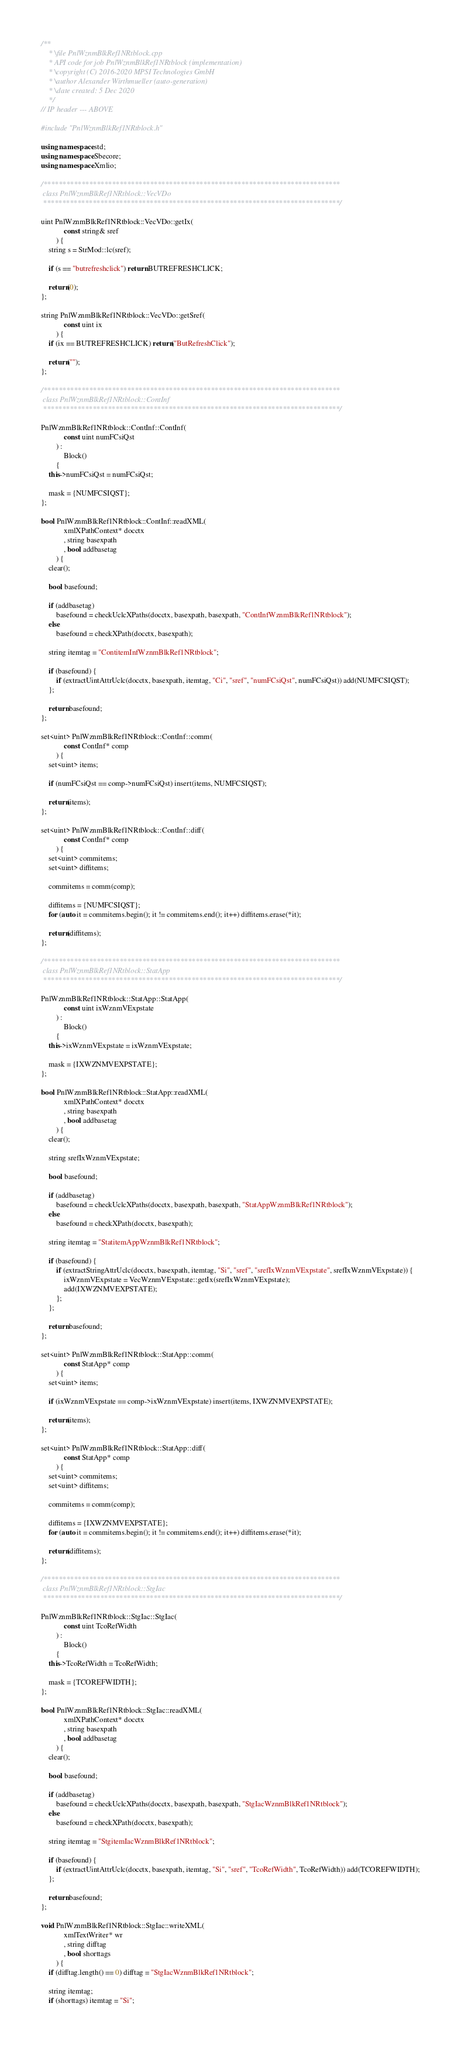Convert code to text. <code><loc_0><loc_0><loc_500><loc_500><_C++_>/**
	* \file PnlWznmBlkRef1NRtblock.cpp
	* API code for job PnlWznmBlkRef1NRtblock (implementation)
	* \copyright (C) 2016-2020 MPSI Technologies GmbH
	* \author Alexander Wirthmueller (auto-generation)
	* \date created: 5 Dec 2020
	*/
// IP header --- ABOVE

#include "PnlWznmBlkRef1NRtblock.h"

using namespace std;
using namespace Sbecore;
using namespace Xmlio;

/******************************************************************************
 class PnlWznmBlkRef1NRtblock::VecVDo
 ******************************************************************************/

uint PnlWznmBlkRef1NRtblock::VecVDo::getIx(
			const string& sref
		) {
	string s = StrMod::lc(sref);

	if (s == "butrefreshclick") return BUTREFRESHCLICK;

	return(0);
};

string PnlWznmBlkRef1NRtblock::VecVDo::getSref(
			const uint ix
		) {
	if (ix == BUTREFRESHCLICK) return("ButRefreshClick");

	return("");
};

/******************************************************************************
 class PnlWznmBlkRef1NRtblock::ContInf
 ******************************************************************************/

PnlWznmBlkRef1NRtblock::ContInf::ContInf(
			const uint numFCsiQst
		) :
			Block()
		{
	this->numFCsiQst = numFCsiQst;

	mask = {NUMFCSIQST};
};

bool PnlWznmBlkRef1NRtblock::ContInf::readXML(
			xmlXPathContext* docctx
			, string basexpath
			, bool addbasetag
		) {
	clear();

	bool basefound;

	if (addbasetag)
		basefound = checkUclcXPaths(docctx, basexpath, basexpath, "ContInfWznmBlkRef1NRtblock");
	else
		basefound = checkXPath(docctx, basexpath);

	string itemtag = "ContitemInfWznmBlkRef1NRtblock";

	if (basefound) {
		if (extractUintAttrUclc(docctx, basexpath, itemtag, "Ci", "sref", "numFCsiQst", numFCsiQst)) add(NUMFCSIQST);
	};

	return basefound;
};

set<uint> PnlWznmBlkRef1NRtblock::ContInf::comm(
			const ContInf* comp
		) {
	set<uint> items;

	if (numFCsiQst == comp->numFCsiQst) insert(items, NUMFCSIQST);

	return(items);
};

set<uint> PnlWznmBlkRef1NRtblock::ContInf::diff(
			const ContInf* comp
		) {
	set<uint> commitems;
	set<uint> diffitems;

	commitems = comm(comp);

	diffitems = {NUMFCSIQST};
	for (auto it = commitems.begin(); it != commitems.end(); it++) diffitems.erase(*it);

	return(diffitems);
};

/******************************************************************************
 class PnlWznmBlkRef1NRtblock::StatApp
 ******************************************************************************/

PnlWznmBlkRef1NRtblock::StatApp::StatApp(
			const uint ixWznmVExpstate
		) :
			Block()
		{
	this->ixWznmVExpstate = ixWznmVExpstate;

	mask = {IXWZNMVEXPSTATE};
};

bool PnlWznmBlkRef1NRtblock::StatApp::readXML(
			xmlXPathContext* docctx
			, string basexpath
			, bool addbasetag
		) {
	clear();

	string srefIxWznmVExpstate;

	bool basefound;

	if (addbasetag)
		basefound = checkUclcXPaths(docctx, basexpath, basexpath, "StatAppWznmBlkRef1NRtblock");
	else
		basefound = checkXPath(docctx, basexpath);

	string itemtag = "StatitemAppWznmBlkRef1NRtblock";

	if (basefound) {
		if (extractStringAttrUclc(docctx, basexpath, itemtag, "Si", "sref", "srefIxWznmVExpstate", srefIxWznmVExpstate)) {
			ixWznmVExpstate = VecWznmVExpstate::getIx(srefIxWznmVExpstate);
			add(IXWZNMVEXPSTATE);
		};
	};

	return basefound;
};

set<uint> PnlWznmBlkRef1NRtblock::StatApp::comm(
			const StatApp* comp
		) {
	set<uint> items;

	if (ixWznmVExpstate == comp->ixWznmVExpstate) insert(items, IXWZNMVEXPSTATE);

	return(items);
};

set<uint> PnlWznmBlkRef1NRtblock::StatApp::diff(
			const StatApp* comp
		) {
	set<uint> commitems;
	set<uint> diffitems;

	commitems = comm(comp);

	diffitems = {IXWZNMVEXPSTATE};
	for (auto it = commitems.begin(); it != commitems.end(); it++) diffitems.erase(*it);

	return(diffitems);
};

/******************************************************************************
 class PnlWznmBlkRef1NRtblock::StgIac
 ******************************************************************************/

PnlWznmBlkRef1NRtblock::StgIac::StgIac(
			const uint TcoRefWidth
		) :
			Block()
		{
	this->TcoRefWidth = TcoRefWidth;

	mask = {TCOREFWIDTH};
};

bool PnlWznmBlkRef1NRtblock::StgIac::readXML(
			xmlXPathContext* docctx
			, string basexpath
			, bool addbasetag
		) {
	clear();

	bool basefound;

	if (addbasetag)
		basefound = checkUclcXPaths(docctx, basexpath, basexpath, "StgIacWznmBlkRef1NRtblock");
	else
		basefound = checkXPath(docctx, basexpath);

	string itemtag = "StgitemIacWznmBlkRef1NRtblock";

	if (basefound) {
		if (extractUintAttrUclc(docctx, basexpath, itemtag, "Si", "sref", "TcoRefWidth", TcoRefWidth)) add(TCOREFWIDTH);
	};

	return basefound;
};

void PnlWznmBlkRef1NRtblock::StgIac::writeXML(
			xmlTextWriter* wr
			, string difftag
			, bool shorttags
		) {
	if (difftag.length() == 0) difftag = "StgIacWznmBlkRef1NRtblock";

	string itemtag;
	if (shorttags) itemtag = "Si";</code> 